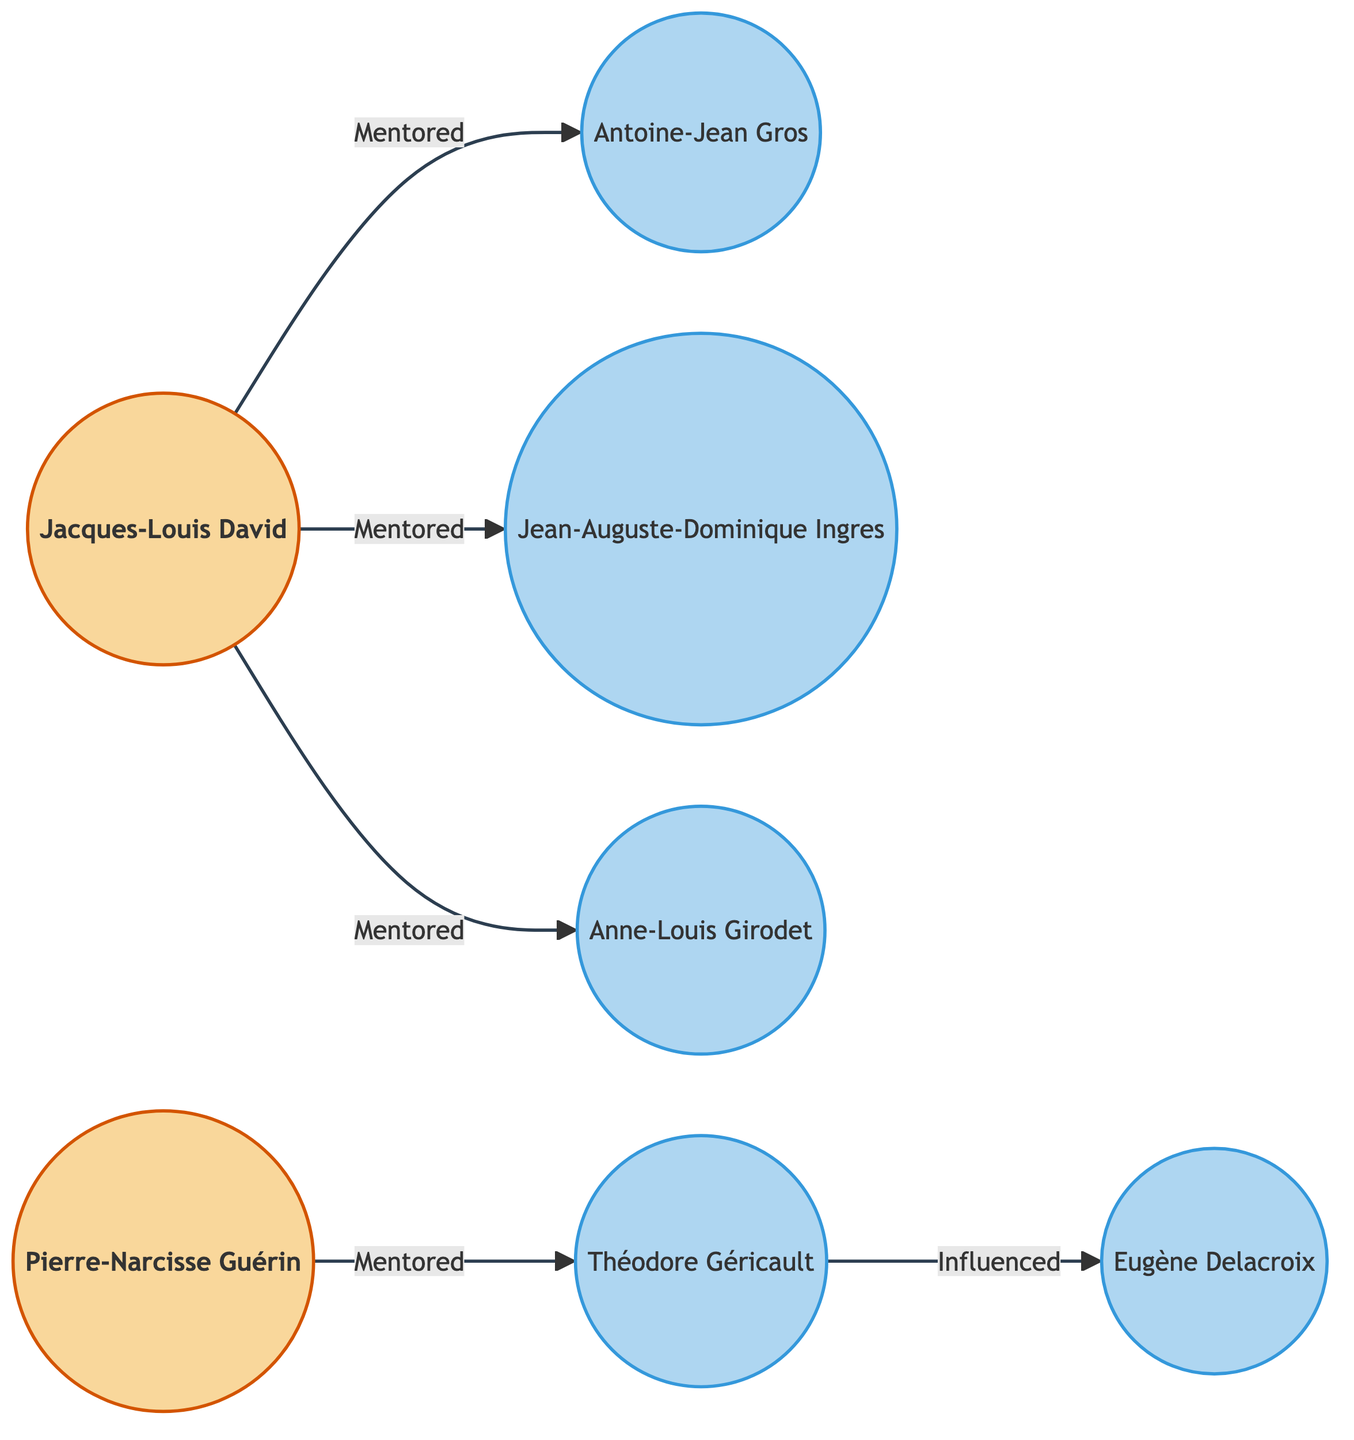What is the total number of nodes in the diagram? The diagram lists several unique entities, which are Jacques-Louis David, Antoine-Jean Gros, Jean-Auguste-Dominique Ingres, Anne-Louis Girodet, Pierre-Narcisse Guérin, Théodore Géricault, and Eugène Delacroix. Counting these gives a total of 7 unique nodes.
Answer: 7 Who mentored Jean-Auguste-Dominique Ingres? By examining the directed graph, there is an arrow pointing from Jacques-Louis David to Jean-Auguste-Dominique Ingres labeled "Mentored," indicating that Jacques-Louis David is the mentor of Ingres.
Answer: Jacques-Louis David What relationship exists between Théodore Géricault and Eugène Delacroix? The directed graph shows an arrow from Théodore Géricault to Eugène Delacroix with the label "Influenced," indicating that Géricault has an influence over Delacroix.
Answer: Influenced How many students were mentored by Jacques-Louis David? Looking at the connections leading out from Jacques-Louis David, we see three arrows leading to Antoine-Jean Gros, Jean-Auguste-Dominique Ingres, and Anne-Louis Girodet, counting to a total of three students mentored by David.
Answer: 3 Which mentor has the most students? Analyzing the directed relationships in the diagram, Jacques-Louis David mentors three students (Antoine-Jean Gros, Jean-Auguste-Dominique Ingres, and Anne-Louis Girodet), while Pierre-Narcisse Guérin only mentors one (Théodore Géricault). Thus, Jacques-Louis David has the most students, with three.
Answer: Jacques-Louis David What is the relationship between Jacques-Louis David and Antoine-Jean Gros? There is an explicit directed edge from Jacques-Louis David to Antoine-Jean Gros labeled "Mentored," clearly indicating the type of relationship as mentorship.
Answer: Mentored Which student is directly influenced by Théodore Géricault? The edge emanating from Théodore Géricault points to Eugène Delacroix and is labeled "Influenced." This shows that Eugène Delacroix is the student who is directly influenced by Géricault.
Answer: Eugène Delacroix 